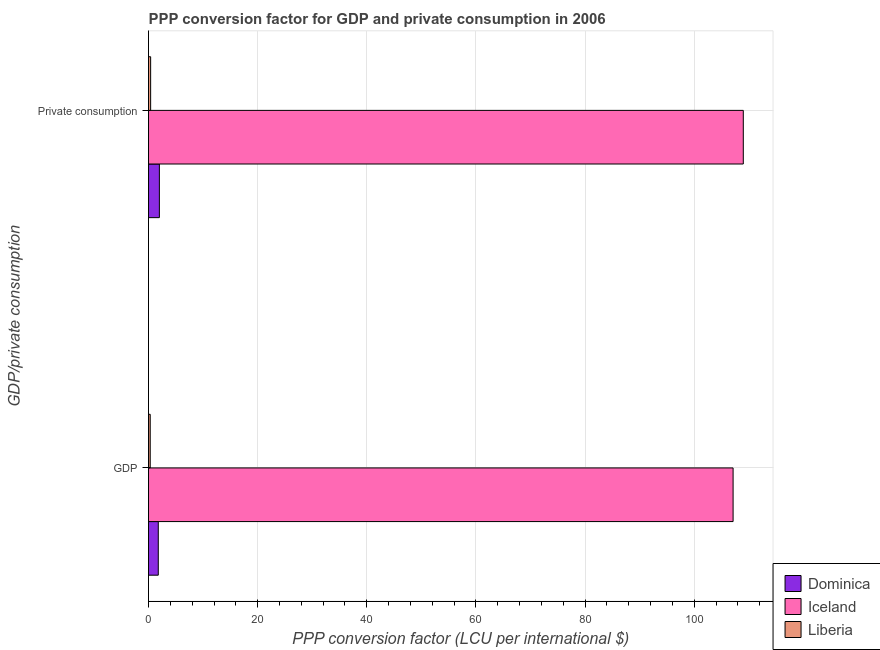How many different coloured bars are there?
Offer a very short reply. 3. Are the number of bars on each tick of the Y-axis equal?
Ensure brevity in your answer.  Yes. What is the label of the 2nd group of bars from the top?
Offer a terse response. GDP. What is the ppp conversion factor for gdp in Iceland?
Your answer should be very brief. 107.12. Across all countries, what is the maximum ppp conversion factor for gdp?
Provide a short and direct response. 107.12. Across all countries, what is the minimum ppp conversion factor for gdp?
Ensure brevity in your answer.  0.31. In which country was the ppp conversion factor for private consumption maximum?
Ensure brevity in your answer.  Iceland. In which country was the ppp conversion factor for private consumption minimum?
Make the answer very short. Liberia. What is the total ppp conversion factor for gdp in the graph?
Keep it short and to the point. 109.22. What is the difference between the ppp conversion factor for private consumption in Iceland and that in Dominica?
Your answer should be compact. 107. What is the difference between the ppp conversion factor for private consumption in Iceland and the ppp conversion factor for gdp in Dominica?
Give a very brief answer. 107.2. What is the average ppp conversion factor for gdp per country?
Keep it short and to the point. 36.41. What is the difference between the ppp conversion factor for gdp and ppp conversion factor for private consumption in Liberia?
Keep it short and to the point. -0.07. What is the ratio of the ppp conversion factor for gdp in Dominica to that in Iceland?
Ensure brevity in your answer.  0.02. In how many countries, is the ppp conversion factor for private consumption greater than the average ppp conversion factor for private consumption taken over all countries?
Your answer should be very brief. 1. What does the 3rd bar from the bottom in  Private consumption represents?
Keep it short and to the point. Liberia. How many bars are there?
Provide a short and direct response. 6. Are all the bars in the graph horizontal?
Keep it short and to the point. Yes. What is the difference between two consecutive major ticks on the X-axis?
Offer a terse response. 20. Where does the legend appear in the graph?
Your response must be concise. Bottom right. How are the legend labels stacked?
Your answer should be compact. Vertical. What is the title of the graph?
Provide a succinct answer. PPP conversion factor for GDP and private consumption in 2006. What is the label or title of the X-axis?
Keep it short and to the point. PPP conversion factor (LCU per international $). What is the label or title of the Y-axis?
Offer a terse response. GDP/private consumption. What is the PPP conversion factor (LCU per international $) of Dominica in GDP?
Offer a terse response. 1.79. What is the PPP conversion factor (LCU per international $) in Iceland in GDP?
Provide a short and direct response. 107.12. What is the PPP conversion factor (LCU per international $) in Liberia in GDP?
Your response must be concise. 0.31. What is the PPP conversion factor (LCU per international $) in Dominica in  Private consumption?
Keep it short and to the point. 1.99. What is the PPP conversion factor (LCU per international $) in Iceland in  Private consumption?
Your answer should be very brief. 108.99. What is the PPP conversion factor (LCU per international $) in Liberia in  Private consumption?
Offer a very short reply. 0.39. Across all GDP/private consumption, what is the maximum PPP conversion factor (LCU per international $) in Dominica?
Provide a succinct answer. 1.99. Across all GDP/private consumption, what is the maximum PPP conversion factor (LCU per international $) of Iceland?
Your response must be concise. 108.99. Across all GDP/private consumption, what is the maximum PPP conversion factor (LCU per international $) of Liberia?
Offer a very short reply. 0.39. Across all GDP/private consumption, what is the minimum PPP conversion factor (LCU per international $) in Dominica?
Your answer should be very brief. 1.79. Across all GDP/private consumption, what is the minimum PPP conversion factor (LCU per international $) of Iceland?
Offer a very short reply. 107.12. Across all GDP/private consumption, what is the minimum PPP conversion factor (LCU per international $) of Liberia?
Your response must be concise. 0.31. What is the total PPP conversion factor (LCU per international $) in Dominica in the graph?
Keep it short and to the point. 3.78. What is the total PPP conversion factor (LCU per international $) of Iceland in the graph?
Offer a very short reply. 216.11. What is the total PPP conversion factor (LCU per international $) in Liberia in the graph?
Ensure brevity in your answer.  0.7. What is the difference between the PPP conversion factor (LCU per international $) in Dominica in GDP and that in  Private consumption?
Keep it short and to the point. -0.2. What is the difference between the PPP conversion factor (LCU per international $) of Iceland in GDP and that in  Private consumption?
Offer a terse response. -1.87. What is the difference between the PPP conversion factor (LCU per international $) of Liberia in GDP and that in  Private consumption?
Provide a short and direct response. -0.07. What is the difference between the PPP conversion factor (LCU per international $) in Dominica in GDP and the PPP conversion factor (LCU per international $) in Iceland in  Private consumption?
Give a very brief answer. -107.2. What is the difference between the PPP conversion factor (LCU per international $) in Dominica in GDP and the PPP conversion factor (LCU per international $) in Liberia in  Private consumption?
Your response must be concise. 1.4. What is the difference between the PPP conversion factor (LCU per international $) of Iceland in GDP and the PPP conversion factor (LCU per international $) of Liberia in  Private consumption?
Provide a succinct answer. 106.74. What is the average PPP conversion factor (LCU per international $) in Dominica per GDP/private consumption?
Offer a terse response. 1.89. What is the average PPP conversion factor (LCU per international $) in Iceland per GDP/private consumption?
Your answer should be very brief. 108.06. What is the average PPP conversion factor (LCU per international $) in Liberia per GDP/private consumption?
Your answer should be very brief. 0.35. What is the difference between the PPP conversion factor (LCU per international $) of Dominica and PPP conversion factor (LCU per international $) of Iceland in GDP?
Provide a short and direct response. -105.33. What is the difference between the PPP conversion factor (LCU per international $) of Dominica and PPP conversion factor (LCU per international $) of Liberia in GDP?
Offer a terse response. 1.48. What is the difference between the PPP conversion factor (LCU per international $) of Iceland and PPP conversion factor (LCU per international $) of Liberia in GDP?
Provide a succinct answer. 106.81. What is the difference between the PPP conversion factor (LCU per international $) in Dominica and PPP conversion factor (LCU per international $) in Iceland in  Private consumption?
Give a very brief answer. -107. What is the difference between the PPP conversion factor (LCU per international $) in Dominica and PPP conversion factor (LCU per international $) in Liberia in  Private consumption?
Your answer should be very brief. 1.6. What is the difference between the PPP conversion factor (LCU per international $) of Iceland and PPP conversion factor (LCU per international $) of Liberia in  Private consumption?
Give a very brief answer. 108.6. What is the ratio of the PPP conversion factor (LCU per international $) of Dominica in GDP to that in  Private consumption?
Keep it short and to the point. 0.9. What is the ratio of the PPP conversion factor (LCU per international $) in Iceland in GDP to that in  Private consumption?
Your answer should be compact. 0.98. What is the ratio of the PPP conversion factor (LCU per international $) in Liberia in GDP to that in  Private consumption?
Your response must be concise. 0.81. What is the difference between the highest and the second highest PPP conversion factor (LCU per international $) of Dominica?
Your answer should be very brief. 0.2. What is the difference between the highest and the second highest PPP conversion factor (LCU per international $) of Iceland?
Provide a succinct answer. 1.87. What is the difference between the highest and the second highest PPP conversion factor (LCU per international $) of Liberia?
Provide a succinct answer. 0.07. What is the difference between the highest and the lowest PPP conversion factor (LCU per international $) of Dominica?
Your answer should be compact. 0.2. What is the difference between the highest and the lowest PPP conversion factor (LCU per international $) in Iceland?
Your answer should be very brief. 1.87. What is the difference between the highest and the lowest PPP conversion factor (LCU per international $) of Liberia?
Your answer should be compact. 0.07. 